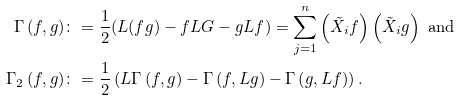Convert formula to latex. <formula><loc_0><loc_0><loc_500><loc_500>\Gamma \left ( f , g \right ) & \colon = \frac { 1 } { 2 } ( L ( f g ) - f L G - g L f ) = \sum _ { j = 1 } ^ { n } \left ( \tilde { X } _ { i } f \right ) \left ( \tilde { X } _ { i } g \right ) \text { and} \\ \Gamma _ { 2 } \left ( f , g \right ) & \colon = \frac { 1 } { 2 } \left ( L \Gamma \left ( f , g \right ) - \Gamma \left ( f , L g \right ) - \Gamma \left ( g , L f \right ) \right ) .</formula> 